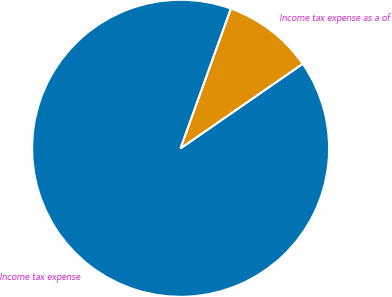<chart> <loc_0><loc_0><loc_500><loc_500><pie_chart><fcel>Income tax expense<fcel>Income tax expense as a of<nl><fcel>90.14%<fcel>9.86%<nl></chart> 